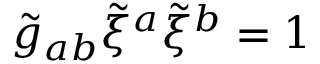<formula> <loc_0><loc_0><loc_500><loc_500>\tilde { g } _ { a b } \tilde { \xi } ^ { a } \tilde { \xi } ^ { b } = 1</formula> 